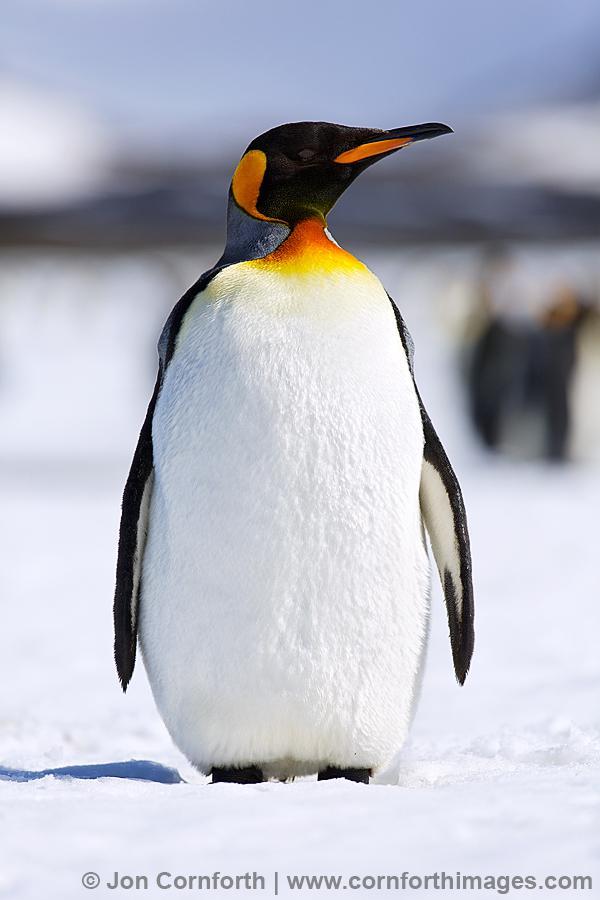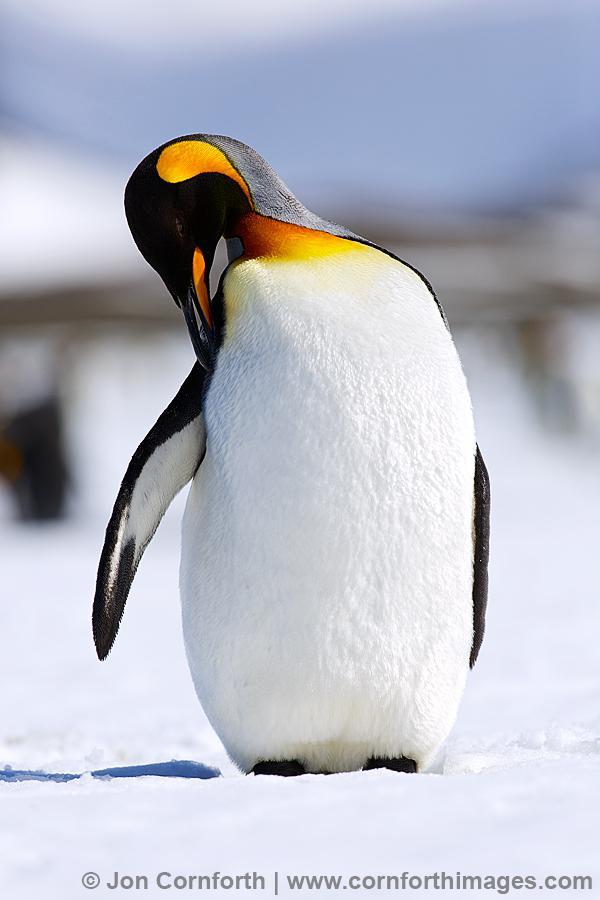The first image is the image on the left, the second image is the image on the right. Considering the images on both sides, is "In one image, exactly four penguins are standing together." valid? Answer yes or no. No. The first image is the image on the left, the second image is the image on the right. Examine the images to the left and right. Is the description "the penguin in the image on the right is looking down" accurate? Answer yes or no. Yes. 